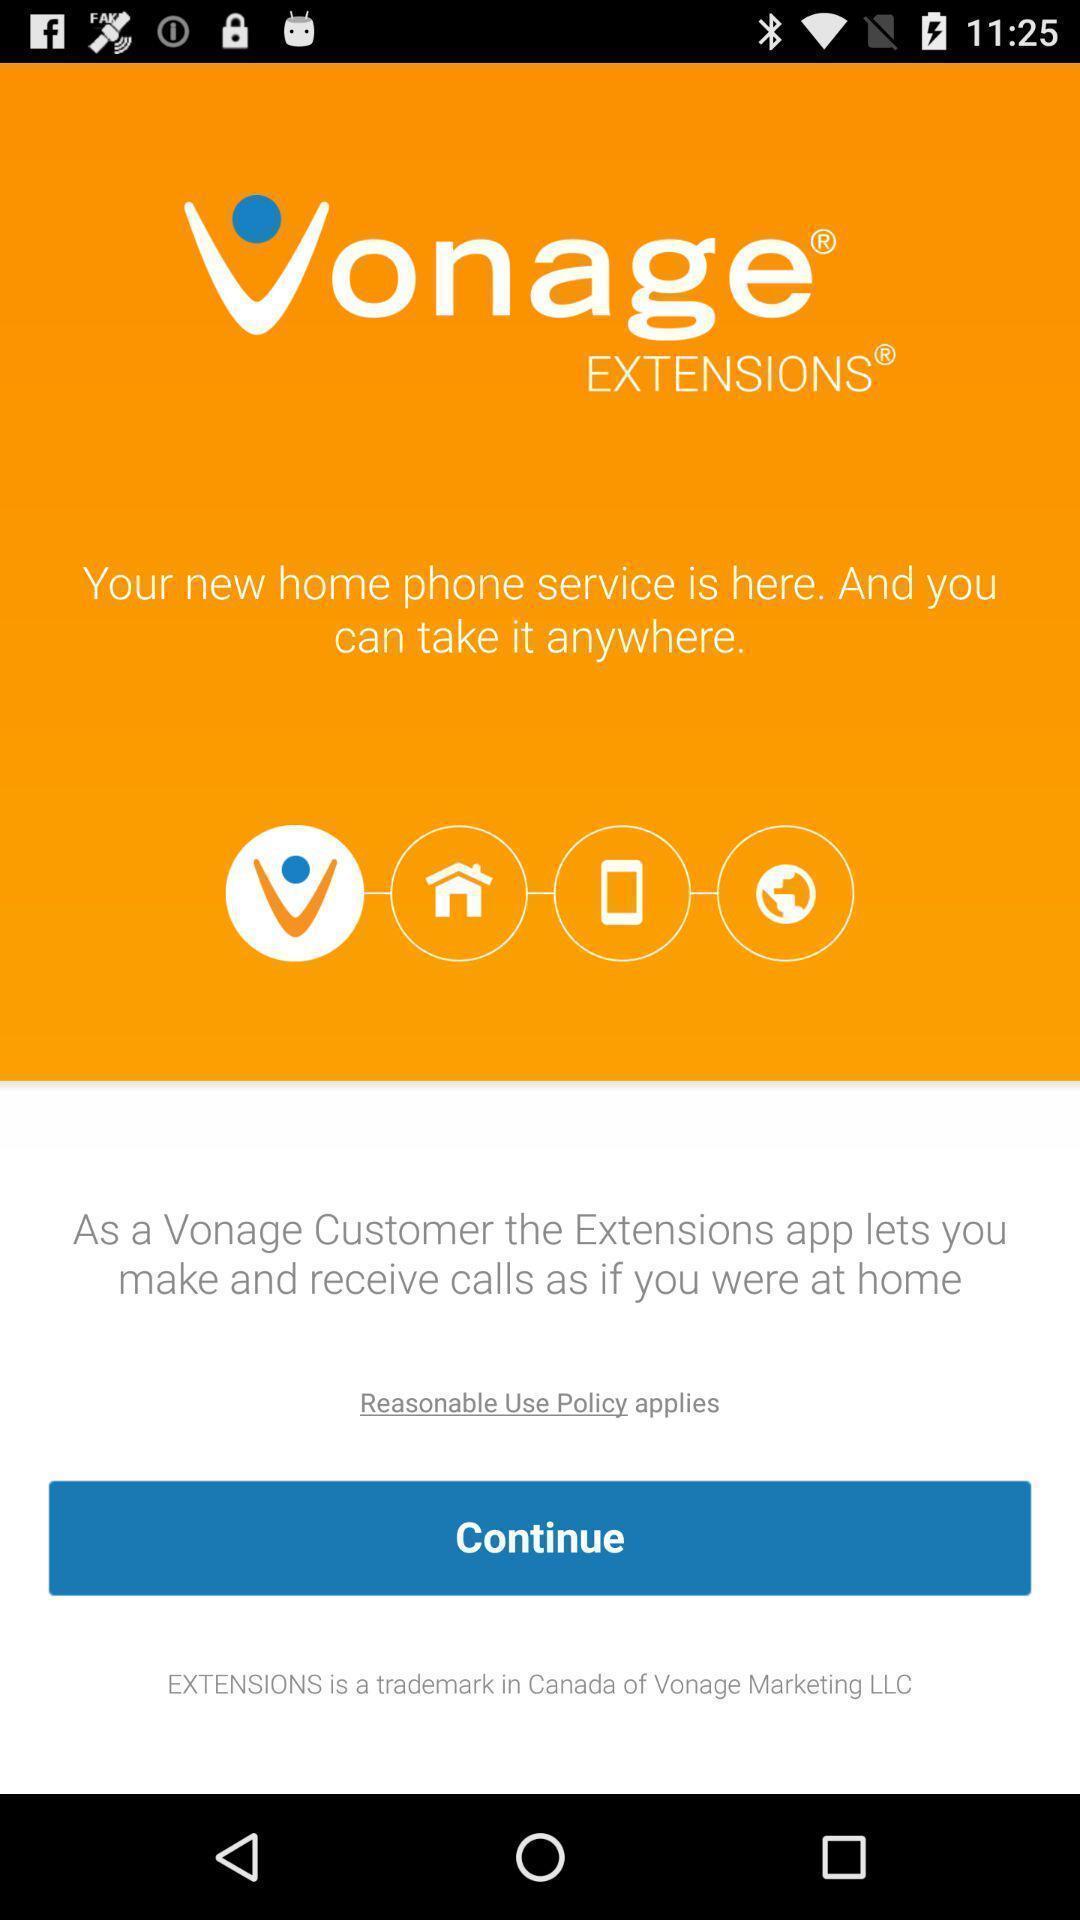Provide a textual representation of this image. Screen shows to continue to next page. 